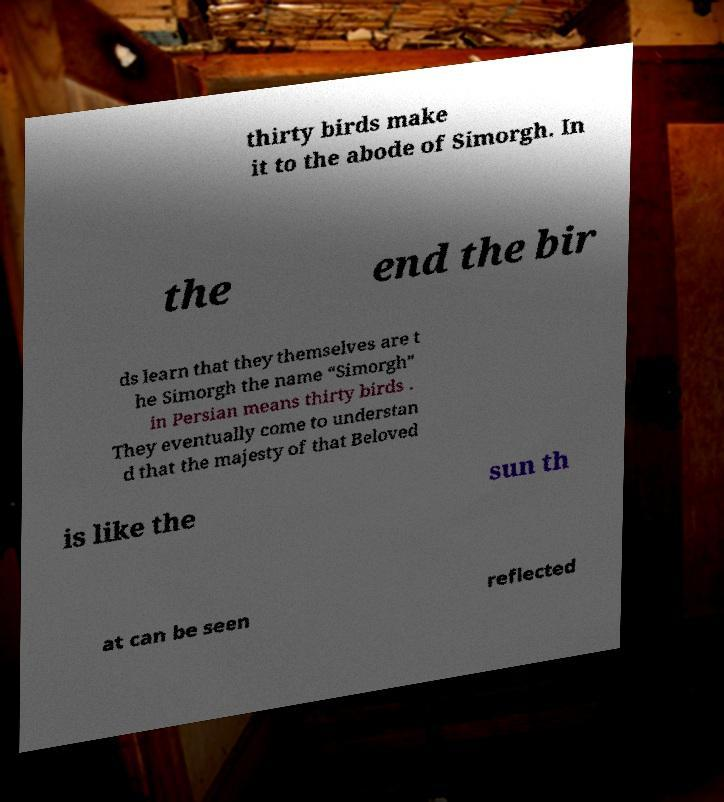Could you extract and type out the text from this image? thirty birds make it to the abode of Simorgh. In the end the bir ds learn that they themselves are t he Simorgh the name “Simorgh” in Persian means thirty birds . They eventually come to understan d that the majesty of that Beloved is like the sun th at can be seen reflected 